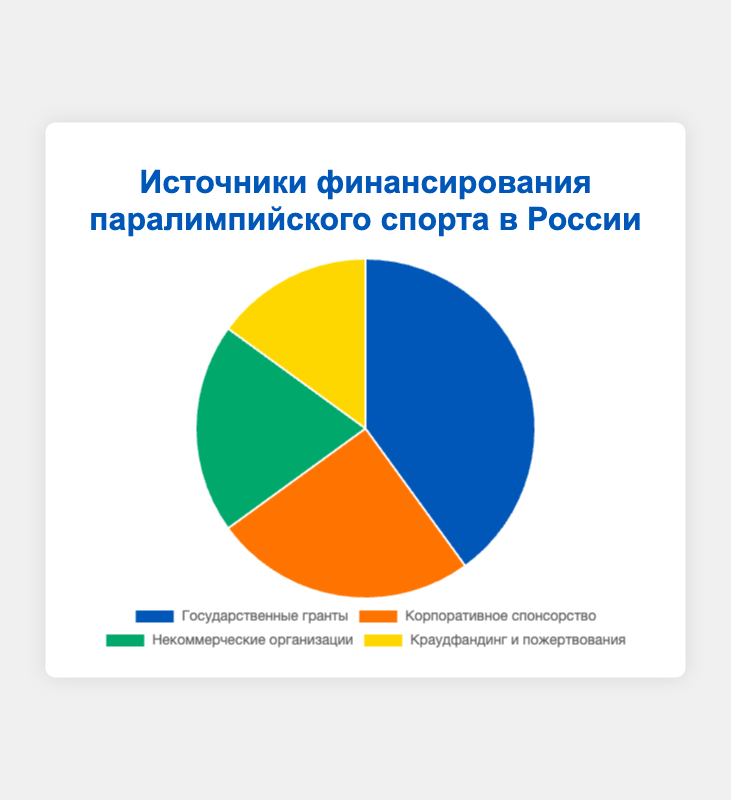Какой источник финансирования имеет наибольший процент? На диаграмме видно, что сегмент, представляющий государственные гранты, самый крупный, а его процент - 40%.
Answer: Государственные гранты Какой источник финансирования имеет наименьший процент? На диаграмме видно, что сегмент, представляющий краудфандинг и пожертвования, самый маленький, а его процент - 15%.
Answer: Краудфандинг и пожертвования Насколько процент государственного финансирования больше процента корпоративного спонсорства? Процент государственного финансирования составляет 40%, а корпоративного спонсорства - 25%. Разница между ними: 40% - 25% = 15%.
Answer: 15% Какова общая доля некоммерческих организаций и краудфандинга/пожертвований? Доля некоммерческих организаций составляет 20%, доля краудфандинга/пожертвований - 15%. Их общая доля: 20% + 15% = 35%.
Answer: 35% Какое число источников финансирования имеют процент выше 20%? Два источника имеют процент выше 20%: государственные гранты - 40% и корпоративное спонсорство - 25%.
Answer: 2 Какая разница в процентах между самым крупным и самым маленьким сегментом финансирования? Сегмент с самой крупной долей - государственные гранты (40%), сегмент с самой маленькой долей - краудфандинг и пожертвования (15%). Разница между ними составляет 40% - 15% = 25%.
Answer: 25% Какой источник финансирования обозначен зелёным цветом? На диаграмме видно, что сегмент, окрашенный в зелёный цвет, соответствует некоммерческим организациям.
Answer: Некоммерческие организации На сколько процентов доля корпоративного спонсорства меньше государственной? Государственное финансирование составляет 40%, а корпоративное спонсорство - 25%. Разница между ними: 40% - 25% = 15%.
Answer: 15% Какова средняя доля трёх наименьших сегментов финансирования? Три наименьших сегмента финансирования: корпоративное спонсорство - 25%, некоммерческие организации - 20%, краудфандинг и пожертвования - 15%. Их средняя доля: (25% + 20% + 15%) / 3 ≈ 20%.
Answer: 20% Сравните вместе доли корпоративного спонсорства и краудфандинга/пожертвований с долей некоммерческих организаций. Что больше и на сколько? Доля корпоративного спонсорства (25%) и доля краудфандинга/пожертвований (15%) в сумме составляют 40%. Доля некоммерческих организаций - 20%. Сумма долей корпоративного спонсорства и краудфандинга/пожертвований больше на 40% - 20% = 20%.
Answer: 20% 